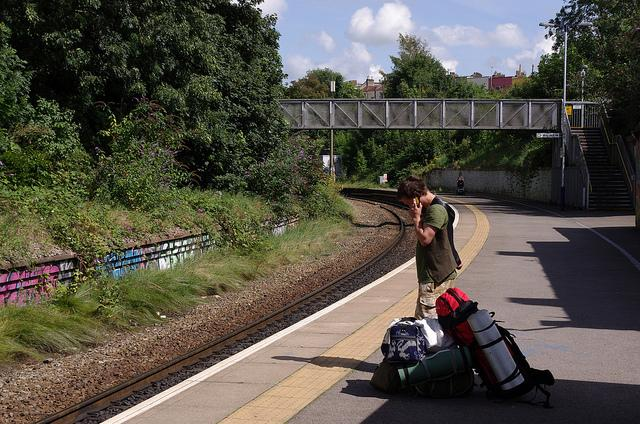If you had to cross to the other side how would you do it? Please explain your reasoning. overhead bridge. Cross over on the bridge. 